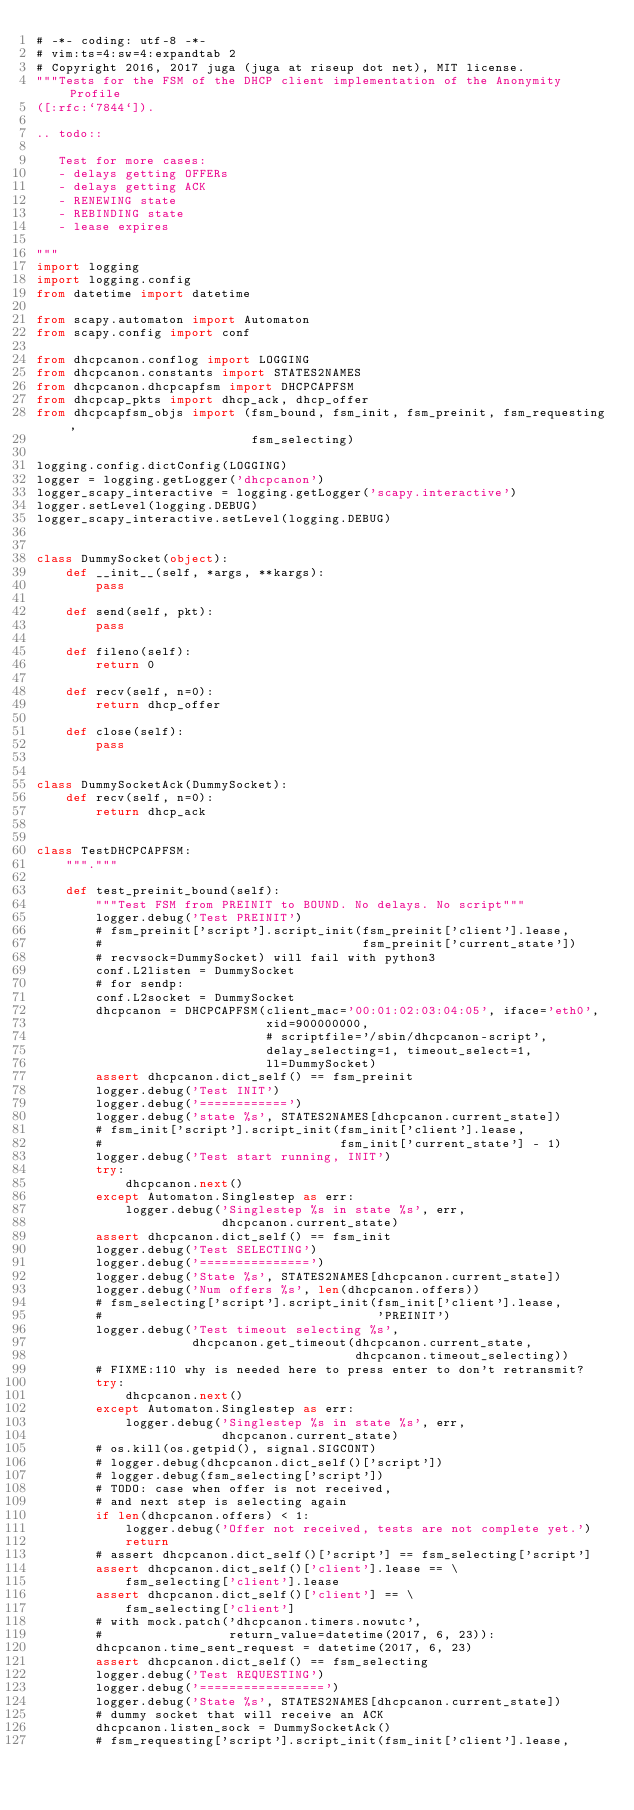Convert code to text. <code><loc_0><loc_0><loc_500><loc_500><_Python_># -*- coding: utf-8 -*-
# vim:ts=4:sw=4:expandtab 2
# Copyright 2016, 2017 juga (juga at riseup dot net), MIT license.
"""Tests for the FSM of the DHCP client implementation of the Anonymity Profile
([:rfc:`7844`]).

.. todo::

   Test for more cases:
   - delays getting OFFERs
   - delays getting ACK
   - RENEWING state
   - REBINDING state
   - lease expires

"""
import logging
import logging.config
from datetime import datetime

from scapy.automaton import Automaton
from scapy.config import conf

from dhcpcanon.conflog import LOGGING
from dhcpcanon.constants import STATES2NAMES
from dhcpcanon.dhcpcapfsm import DHCPCAPFSM
from dhcpcap_pkts import dhcp_ack, dhcp_offer
from dhcpcapfsm_objs import (fsm_bound, fsm_init, fsm_preinit, fsm_requesting,
                             fsm_selecting)

logging.config.dictConfig(LOGGING)
logger = logging.getLogger('dhcpcanon')
logger_scapy_interactive = logging.getLogger('scapy.interactive')
logger.setLevel(logging.DEBUG)
logger_scapy_interactive.setLevel(logging.DEBUG)


class DummySocket(object):
    def __init__(self, *args, **kargs):
        pass

    def send(self, pkt):
        pass

    def fileno(self):
        return 0

    def recv(self, n=0):
        return dhcp_offer

    def close(self):
        pass


class DummySocketAck(DummySocket):
    def recv(self, n=0):
        return dhcp_ack


class TestDHCPCAPFSM:
    """."""

    def test_preinit_bound(self):
        """Test FSM from PREINIT to BOUND. No delays. No script"""
        logger.debug('Test PREINIT')
        # fsm_preinit['script'].script_init(fsm_preinit['client'].lease,
        #                                   fsm_preinit['current_state'])
        # recvsock=DummySocket) will fail with python3
        conf.L2listen = DummySocket
        # for sendp:
        conf.L2socket = DummySocket
        dhcpcanon = DHCPCAPFSM(client_mac='00:01:02:03:04:05', iface='eth0',
                               xid=900000000,
                               # scriptfile='/sbin/dhcpcanon-script',
                               delay_selecting=1, timeout_select=1,
                               ll=DummySocket)
        assert dhcpcanon.dict_self() == fsm_preinit
        logger.debug('Test INIT')
        logger.debug('============')
        logger.debug('state %s', STATES2NAMES[dhcpcanon.current_state])
        # fsm_init['script'].script_init(fsm_init['client'].lease,
        #                                fsm_init['current_state'] - 1)
        logger.debug('Test start running, INIT')
        try:
            dhcpcanon.next()
        except Automaton.Singlestep as err:
            logger.debug('Singlestep %s in state %s', err,
                         dhcpcanon.current_state)
        assert dhcpcanon.dict_self() == fsm_init
        logger.debug('Test SELECTING')
        logger.debug('===============')
        logger.debug('State %s', STATES2NAMES[dhcpcanon.current_state])
        logger.debug('Num offers %s', len(dhcpcanon.offers))
        # fsm_selecting['script'].script_init(fsm_init['client'].lease,
        #                                     'PREINIT')
        logger.debug('Test timeout selecting %s',
                     dhcpcanon.get_timeout(dhcpcanon.current_state,
                                           dhcpcanon.timeout_selecting))
        # FIXME:110 why is needed here to press enter to don't retransmit?
        try:
            dhcpcanon.next()
        except Automaton.Singlestep as err:
            logger.debug('Singlestep %s in state %s', err,
                         dhcpcanon.current_state)
        # os.kill(os.getpid(), signal.SIGCONT)
        # logger.debug(dhcpcanon.dict_self()['script'])
        # logger.debug(fsm_selecting['script'])
        # TODO: case when offer is not received,
        # and next step is selecting again
        if len(dhcpcanon.offers) < 1:
            logger.debug('Offer not received, tests are not complete yet.')
            return
        # assert dhcpcanon.dict_self()['script'] == fsm_selecting['script']
        assert dhcpcanon.dict_self()['client'].lease == \
            fsm_selecting['client'].lease
        assert dhcpcanon.dict_self()['client'] == \
            fsm_selecting['client']
        # with mock.patch('dhcpcanon.timers.nowutc',
        #                 return_value=datetime(2017, 6, 23)):
        dhcpcanon.time_sent_request = datetime(2017, 6, 23)
        assert dhcpcanon.dict_self() == fsm_selecting
        logger.debug('Test REQUESTING')
        logger.debug('=================')
        logger.debug('State %s', STATES2NAMES[dhcpcanon.current_state])
        # dummy socket that will receive an ACK
        dhcpcanon.listen_sock = DummySocketAck()
        # fsm_requesting['script'].script_init(fsm_init['client'].lease,</code> 